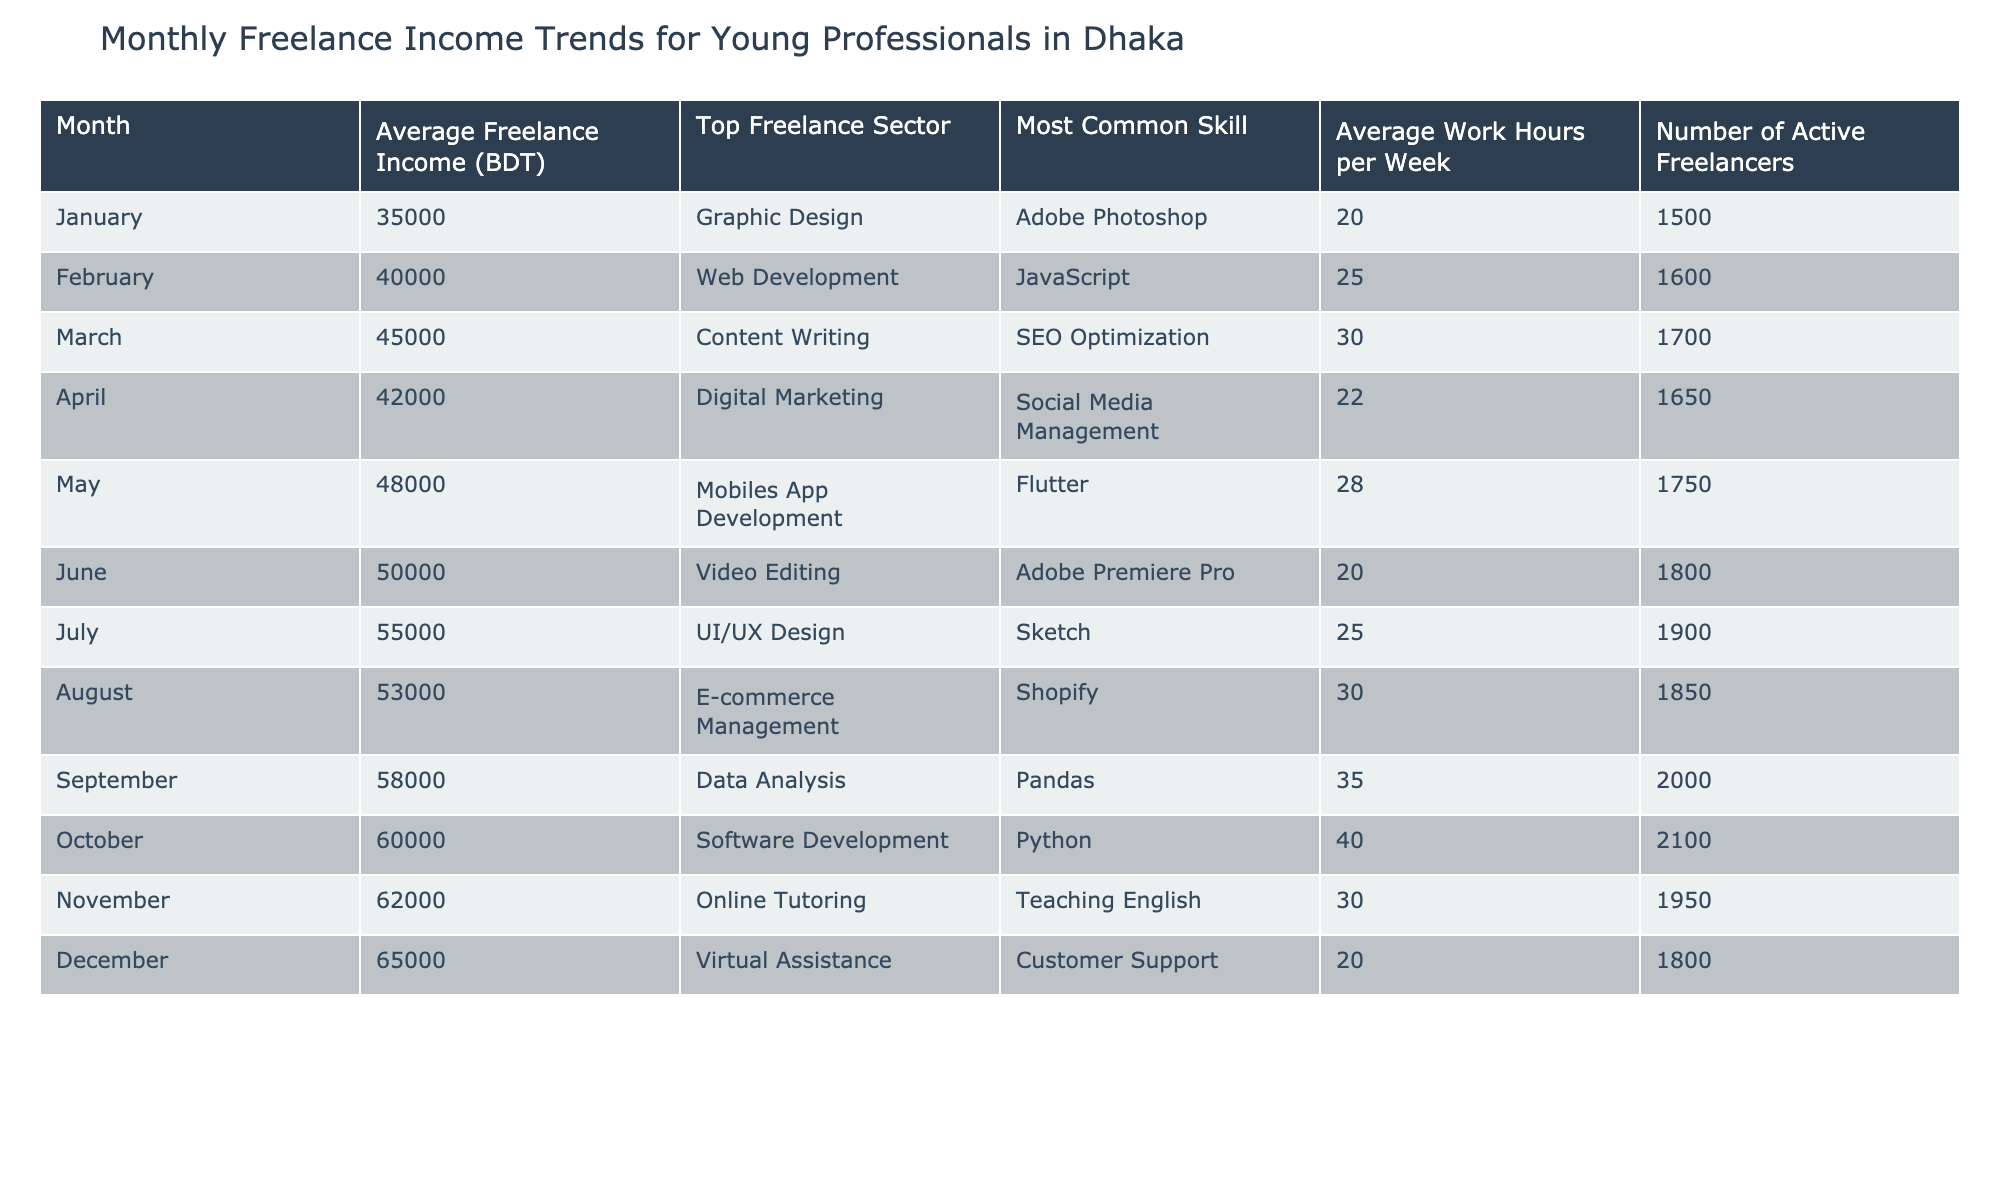What is the average freelance income in December? The table lists December's average freelance income as 65000 BDT.
Answer: 65000 BDT Which freelance sector had the highest average income in October? According to the table, the highest average income is in Software Development at 60000 BDT.
Answer: Software Development What was the increase in average freelance income from January to March? The average income in January was 35000 BDT, and in March it was 45000 BDT. The increase is calculated as 45000 - 35000 = 10000 BDT.
Answer: 10000 BDT Is the most common skill in July UI/UX Design? The table lists the most common skill in July as Sketch, not UI/UX Design. Therefore, the statement is false.
Answer: No What is the average work hours per week for freelancers in September? From the table, the average work hours per week for September is stated as 35 hours.
Answer: 35 hours How much higher was the average freelance income in November compared to January? The average income in November was 62000 BDT and in January it was 35000 BDT. The difference is 62000 - 35000 = 27000 BDT.
Answer: 27000 BDT What is the total number of active freelancers in April and May combined? The number of active freelancers in April is 1650, and in May it is 1750. Adding these gives 1650 + 1750 = 3400 freelancers combined.
Answer: 3400 freelancers Which month had the most active freelancers, and what was their number? The table shows that October had the most active freelancers at 2100.
Answer: October, 2100 freelancers Is Digital Marketing the top freelance sector in July? The table indicates that the top sector in July is UI/UX Design, therefore, the statement is false.
Answer: No 